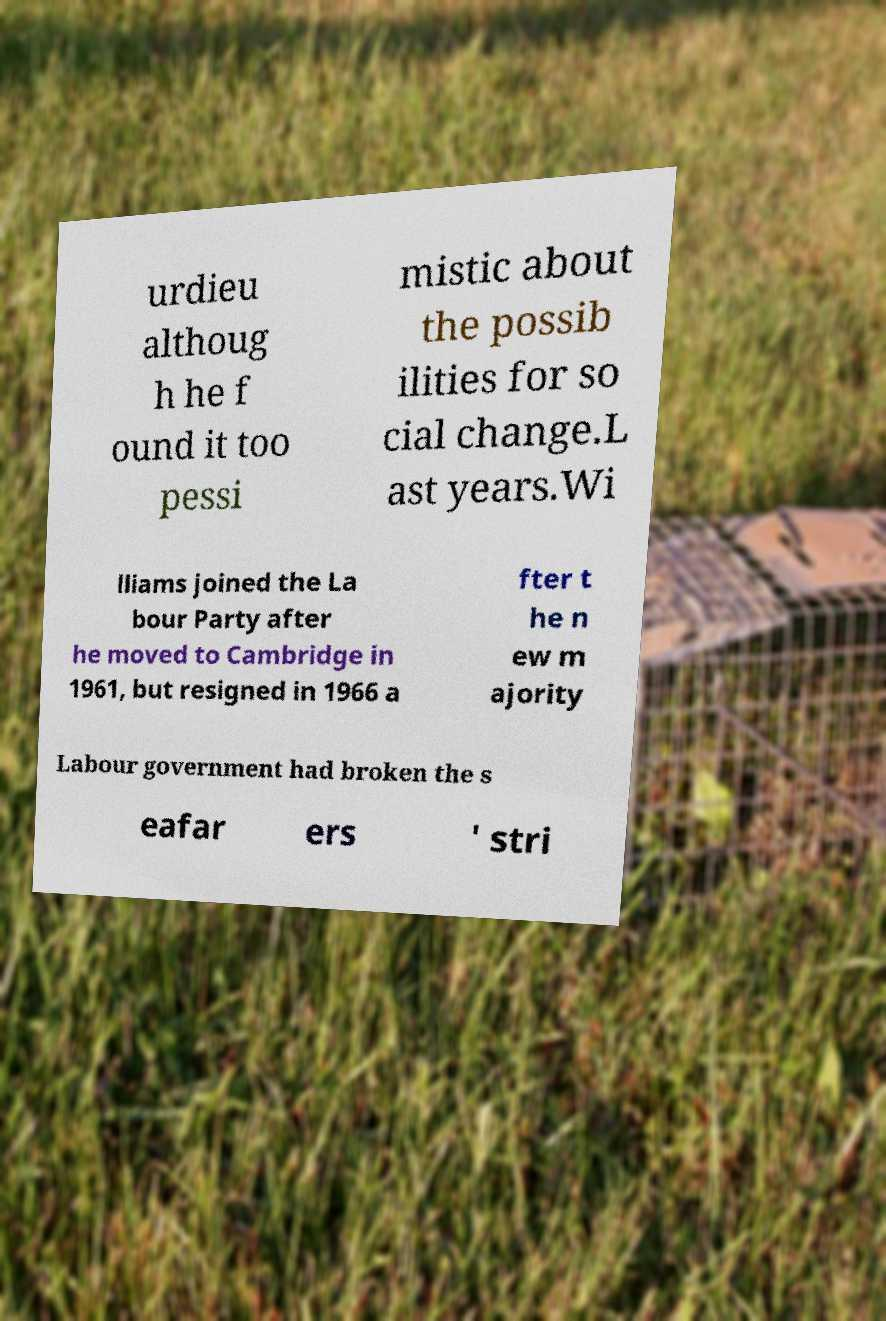Can you read and provide the text displayed in the image?This photo seems to have some interesting text. Can you extract and type it out for me? urdieu althoug h he f ound it too pessi mistic about the possib ilities for so cial change.L ast years.Wi lliams joined the La bour Party after he moved to Cambridge in 1961, but resigned in 1966 a fter t he n ew m ajority Labour government had broken the s eafar ers ' stri 